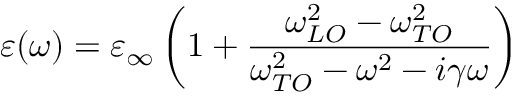<formula> <loc_0><loc_0><loc_500><loc_500>\varepsilon ( \omega ) = \varepsilon _ { \infty } \left ( 1 + \frac { \omega _ { L O } ^ { 2 } - \omega _ { T O } ^ { 2 } } { \omega _ { T O } ^ { 2 } - \omega ^ { 2 } - i \gamma \omega } \right )</formula> 